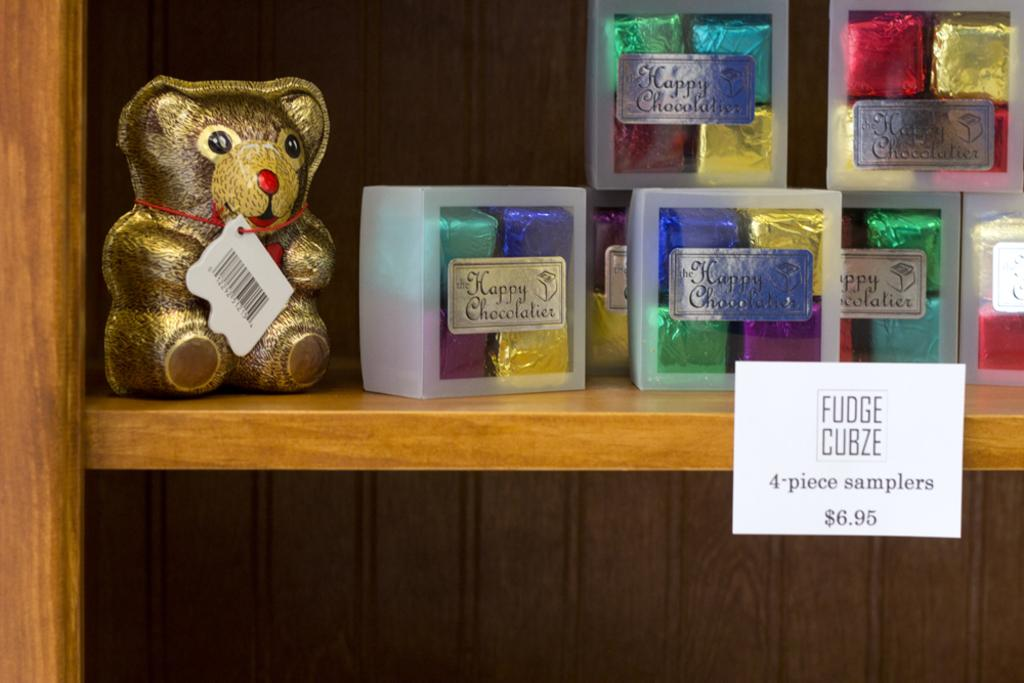Provide a one-sentence caption for the provided image. a display of Fudge Cubze 4 piece sampler for $6.95. 